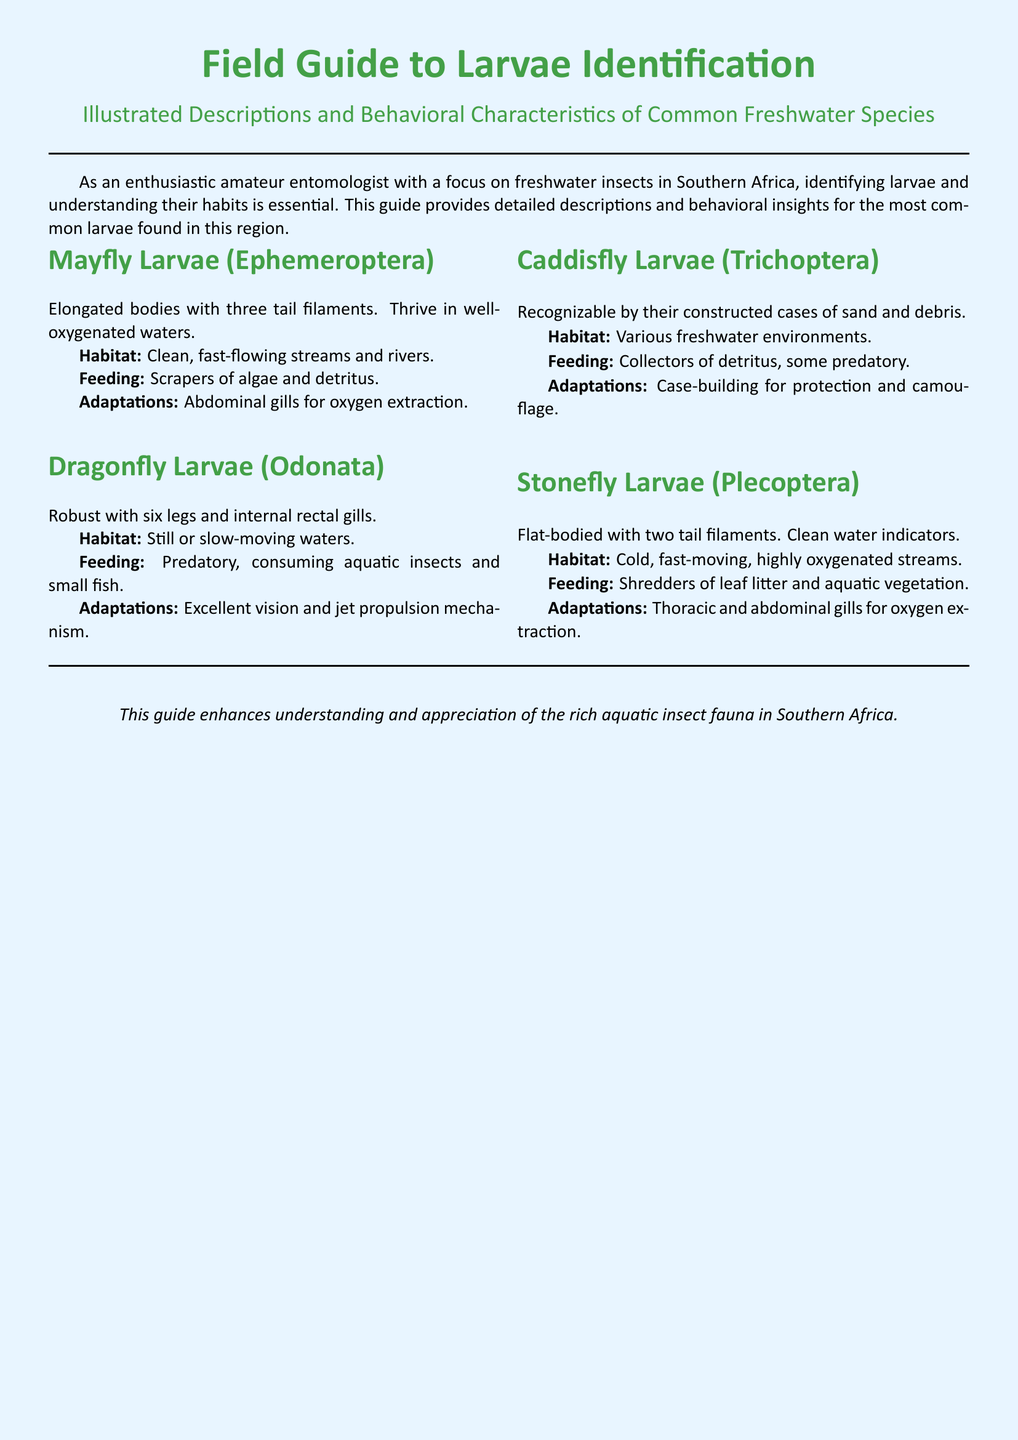What is the title of the guide? The title is presented at the top of the document, encapsulating the primary subject being addressed, which is the identification of larvae.
Answer: Field Guide to Larvae Identification What is the primary focus of the guide? The guide primarily aims to assist amateur entomologists in identifying freshwater insect larvae and understanding their behaviors.
Answer: Freshwater insects What type of habitat do Mayfly larvae thrive in? The habitat description indicates the environment where Mayfly larvae are commonly found, which is essential for their survival.
Answer: Clean, fast-flowing streams and rivers What do Dragonfly larvae feed on? The feeding habits of Dragonfly larvae are described, giving insight into their role in the aquatic ecosystem.
Answer: Aquatic insects and small fish What adaptations do Caddisfly larvae utilize for protection? The description highlights a specific behavioral adaptation that Caddisfly larvae use to evade predators, which is important for their survival.
Answer: Case-building How many gills do Stonefly larvae have? The adaptation section indicates how many types of gills are utilized by Stonefly larvae for oxygen extraction in their habitat.
Answer: Thoracic and abdominal gills What kind of water indicates the presence of Stonefly larvae? The document provides an ecological indicator that helps assess water quality through the presence of a particular species of larvae.
Answer: Clean water What method do Dragonfly larvae use for movement? The behavioral characteristic provides an understanding of how Dragonfly larvae navigate their environment effectively.
Answer: Jet propulsion mechanism Which section covers behavioral characteristics? The document is organized into sections that detail both characteristics and habitats, focusing on specific categories of larvae.
Answer: All sections contain behavioral characteristics 